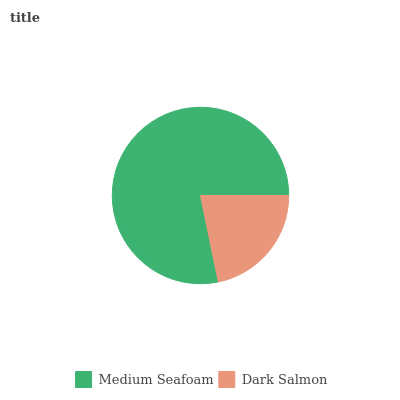Is Dark Salmon the minimum?
Answer yes or no. Yes. Is Medium Seafoam the maximum?
Answer yes or no. Yes. Is Dark Salmon the maximum?
Answer yes or no. No. Is Medium Seafoam greater than Dark Salmon?
Answer yes or no. Yes. Is Dark Salmon less than Medium Seafoam?
Answer yes or no. Yes. Is Dark Salmon greater than Medium Seafoam?
Answer yes or no. No. Is Medium Seafoam less than Dark Salmon?
Answer yes or no. No. Is Medium Seafoam the high median?
Answer yes or no. Yes. Is Dark Salmon the low median?
Answer yes or no. Yes. Is Dark Salmon the high median?
Answer yes or no. No. Is Medium Seafoam the low median?
Answer yes or no. No. 